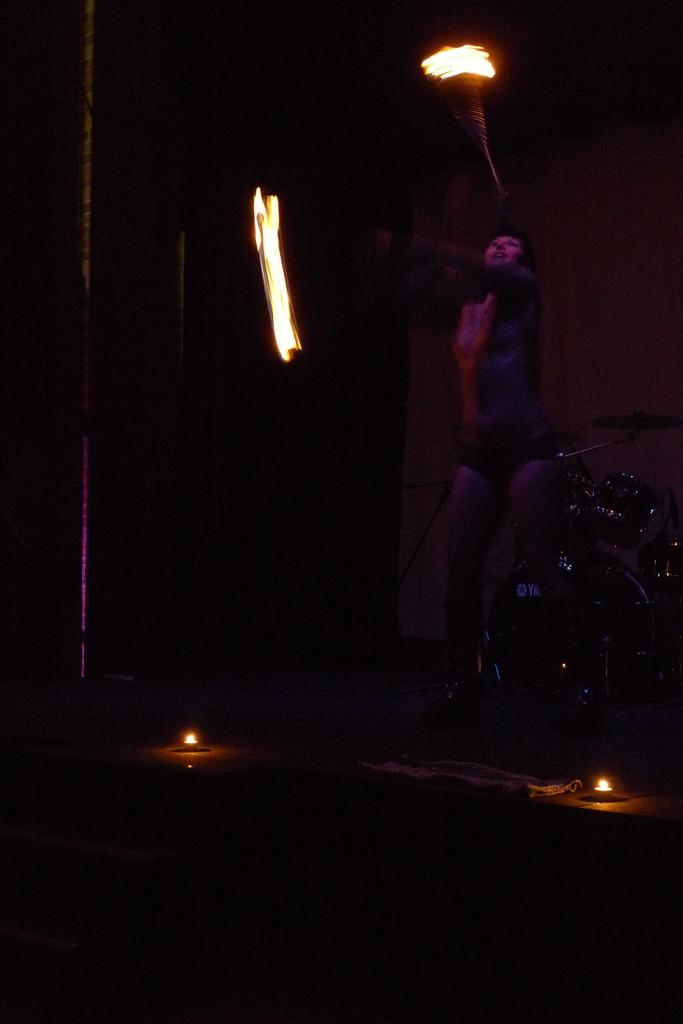Who or what is present in the image? There is a person in the image. What else can be seen in the image besides the person? There are musical instruments in the image. Are there any additional features at the bottom of the image? Yes, there are lights at the bottom of the image. What can be seen in the background of the image? There is a wall in the background of the image. What type of yarn is being used by the person in the image? There is no yarn present in the image; the person is not engaged in any activity involving yarn. 